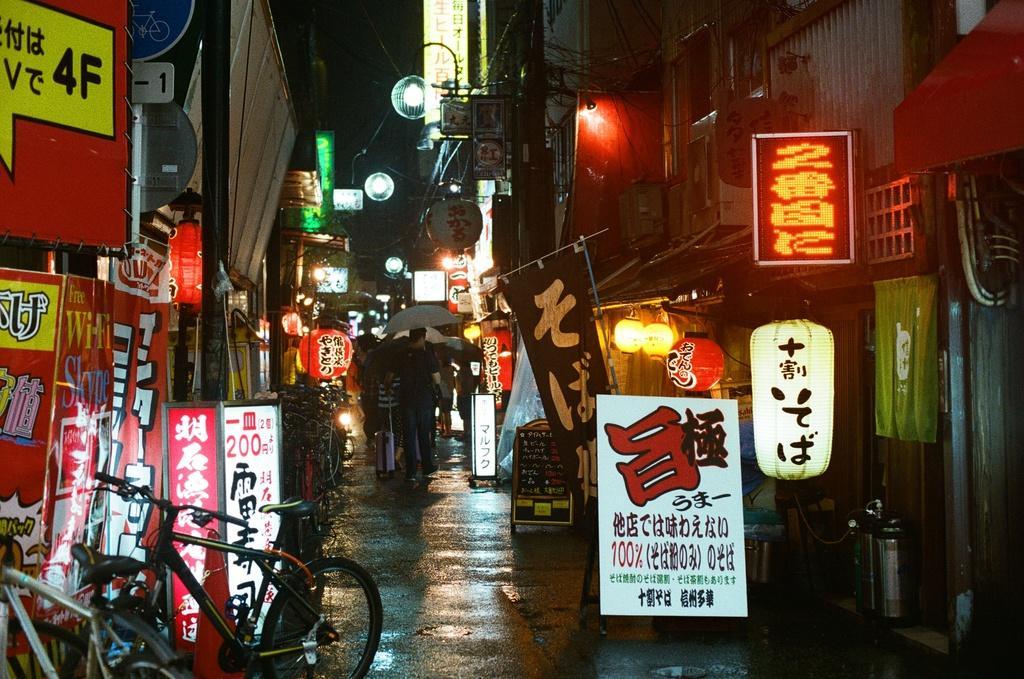Please provide a concise description of this image. In this image I can see road and on it I can see few people are standing. I can also see few of them are holding umbrellas. Here I can see number of buildings, number of boards, number of lights, for bicycles and on these words I can see something is written. 